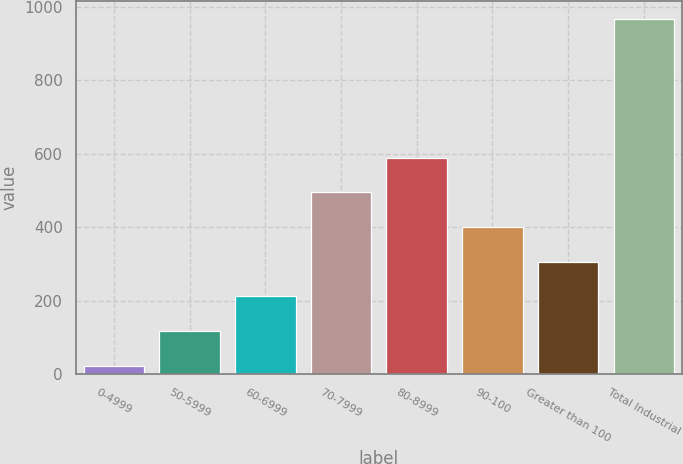Convert chart to OTSL. <chart><loc_0><loc_0><loc_500><loc_500><bar_chart><fcel>0-4999<fcel>50-5999<fcel>60-6999<fcel>70-7999<fcel>80-8999<fcel>90-100<fcel>Greater than 100<fcel>Total Industrial<nl><fcel>23<fcel>117.5<fcel>212<fcel>495.5<fcel>590<fcel>401<fcel>306.5<fcel>968<nl></chart> 